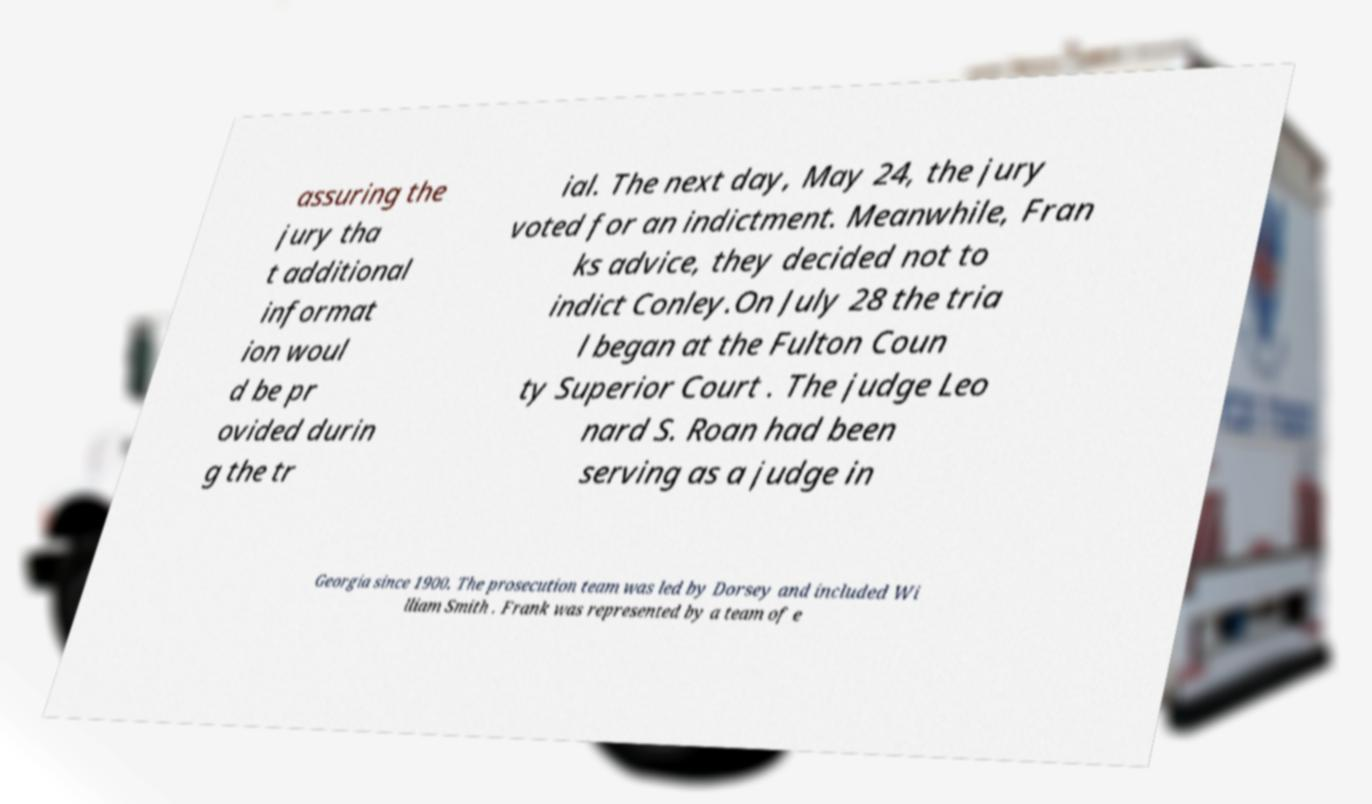I need the written content from this picture converted into text. Can you do that? assuring the jury tha t additional informat ion woul d be pr ovided durin g the tr ial. The next day, May 24, the jury voted for an indictment. Meanwhile, Fran ks advice, they decided not to indict Conley.On July 28 the tria l began at the Fulton Coun ty Superior Court . The judge Leo nard S. Roan had been serving as a judge in Georgia since 1900. The prosecution team was led by Dorsey and included Wi lliam Smith . Frank was represented by a team of e 